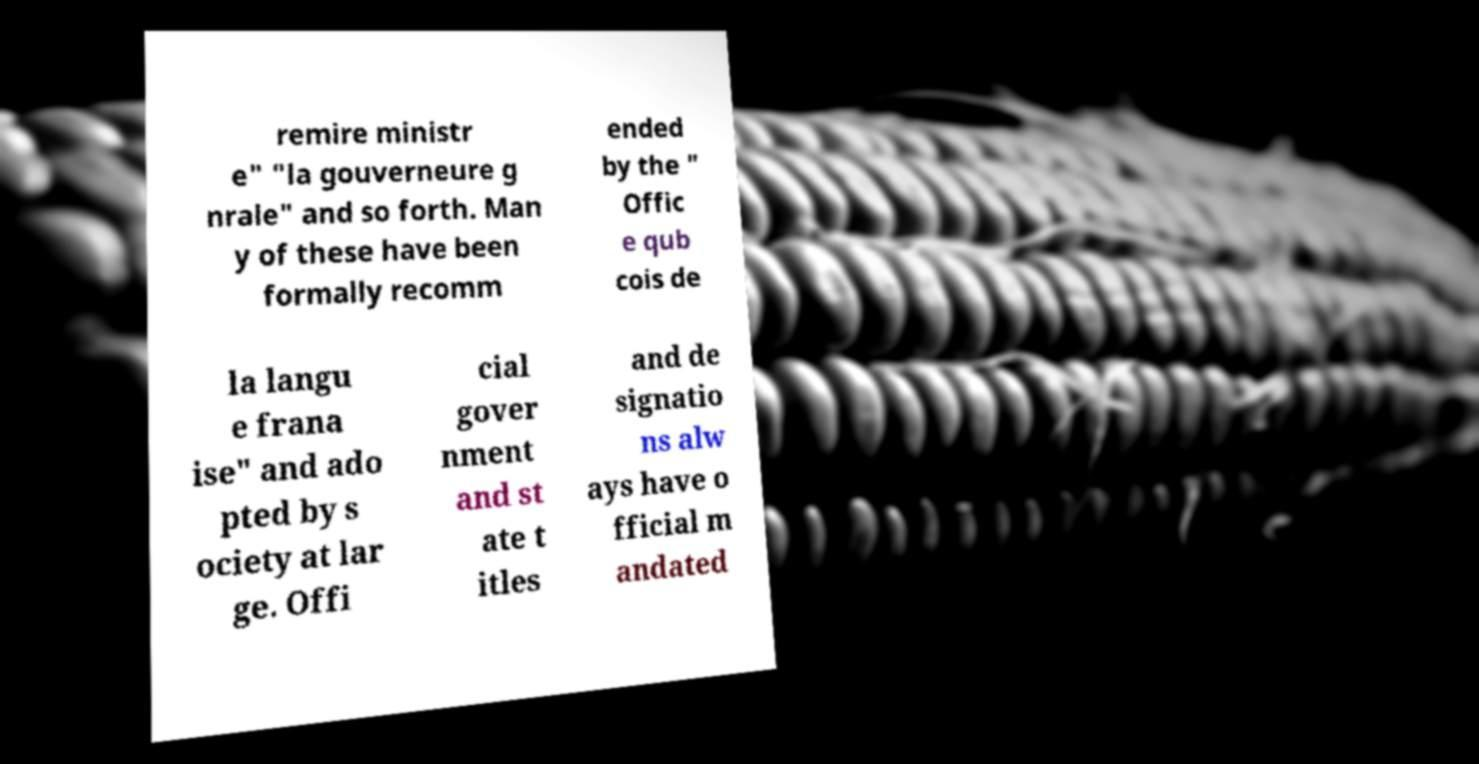For documentation purposes, I need the text within this image transcribed. Could you provide that? remire ministr e" "la gouverneure g nrale" and so forth. Man y of these have been formally recomm ended by the " Offic e qub cois de la langu e frana ise" and ado pted by s ociety at lar ge. Offi cial gover nment and st ate t itles and de signatio ns alw ays have o fficial m andated 